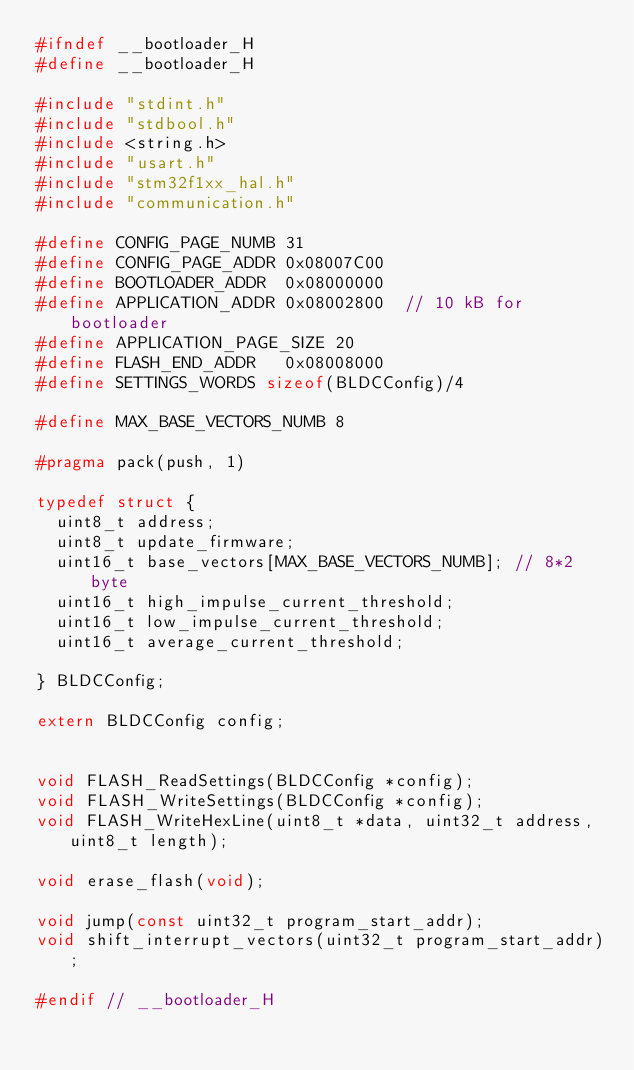<code> <loc_0><loc_0><loc_500><loc_500><_C_>#ifndef __bootloader_H
#define __bootloader_H

#include "stdint.h"
#include "stdbool.h"
#include <string.h>
#include "usart.h"
#include "stm32f1xx_hal.h"
#include "communication.h"

#define CONFIG_PAGE_NUMB 31
#define CONFIG_PAGE_ADDR 0x08007C00
#define BOOTLOADER_ADDR  0x08000000
#define APPLICATION_ADDR 0x08002800  // 10 kB for bootloader
#define APPLICATION_PAGE_SIZE 20
#define FLASH_END_ADDR   0x08008000
#define SETTINGS_WORDS sizeof(BLDCConfig)/4
	
#define MAX_BASE_VECTORS_NUMB 8

#pragma pack(push, 1)

typedef struct { 
	uint8_t address;
	uint8_t update_firmware;
	uint16_t base_vectors[MAX_BASE_VECTORS_NUMB]; // 8*2 byte
	uint16_t high_impulse_current_threshold;
	uint16_t low_impulse_current_threshold;
	uint16_t average_current_threshold;
	
} BLDCConfig;

extern BLDCConfig config;


void FLASH_ReadSettings(BLDCConfig *config);
void FLASH_WriteSettings(BLDCConfig *config);
void FLASH_WriteHexLine(uint8_t *data, uint32_t address, uint8_t length);

void erase_flash(void);
	
void jump(const uint32_t program_start_addr);
void shift_interrupt_vectors(uint32_t program_start_addr);

#endif // __bootloader_H
</code> 